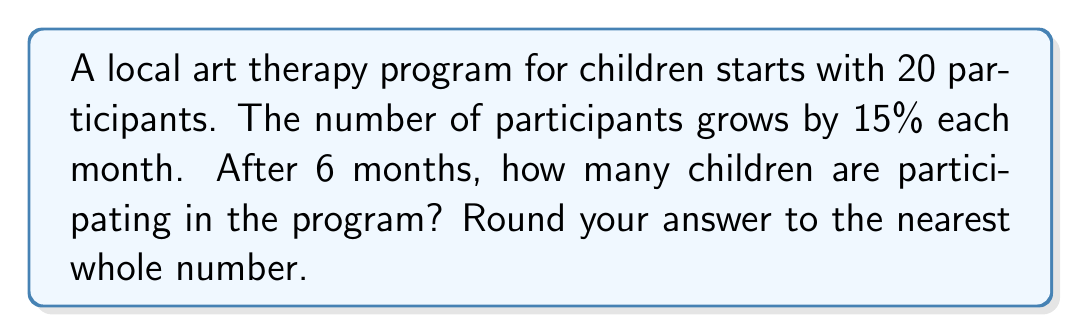Could you help me with this problem? Let's approach this step-by-step:

1) The initial number of participants is 20.

2) The growth rate is 15% per month, which as a decimal is 0.15.

3) We need to calculate the number of participants after 6 months.

4) The formula for exponential growth is:

   $A = P(1 + r)^t$

   Where:
   $A$ = final amount
   $P$ = initial principal balance
   $r$ = growth rate (as a decimal)
   $t$ = time period

5) Plugging in our values:

   $A = 20(1 + 0.15)^6$

6) Let's calculate:

   $A = 20(1.15)^6$
   $A = 20 * 2.3131$
   $A = 46.262$

7) Rounding to the nearest whole number:

   $A \approx 46$
Answer: 46 children 